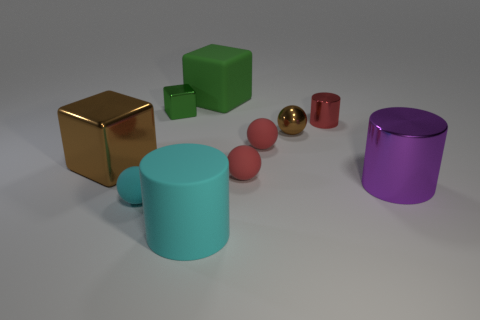Is the brown thing to the right of the big brown cube made of the same material as the tiny cyan thing?
Make the answer very short. No. The large thing that is made of the same material as the cyan cylinder is what color?
Keep it short and to the point. Green. Is the number of red matte spheres that are behind the small metal cylinder less than the number of red rubber objects that are behind the large green object?
Ensure brevity in your answer.  No. There is a object that is behind the small green block; does it have the same color as the matte object that is left of the cyan cylinder?
Make the answer very short. No. Is there a large gray cube that has the same material as the large brown cube?
Provide a succinct answer. No. There is a thing that is right of the tiny red metallic cylinder that is behind the big purple metal cylinder; what size is it?
Your response must be concise. Large. Are there more tiny gray balls than large cylinders?
Ensure brevity in your answer.  No. There is a cylinder behind the brown ball; is its size the same as the big cyan rubber cylinder?
Provide a succinct answer. No. What number of small shiny cylinders have the same color as the small shiny ball?
Your response must be concise. 0. Does the large brown shiny object have the same shape as the big green rubber object?
Keep it short and to the point. Yes. 